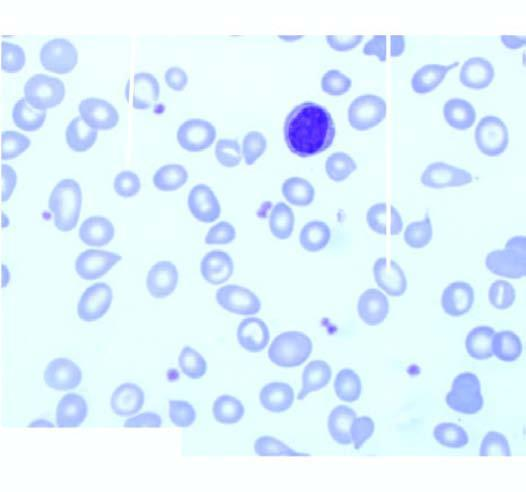s the centre moderate microcytosis and hypochromia?
Answer the question using a single word or phrase. No 